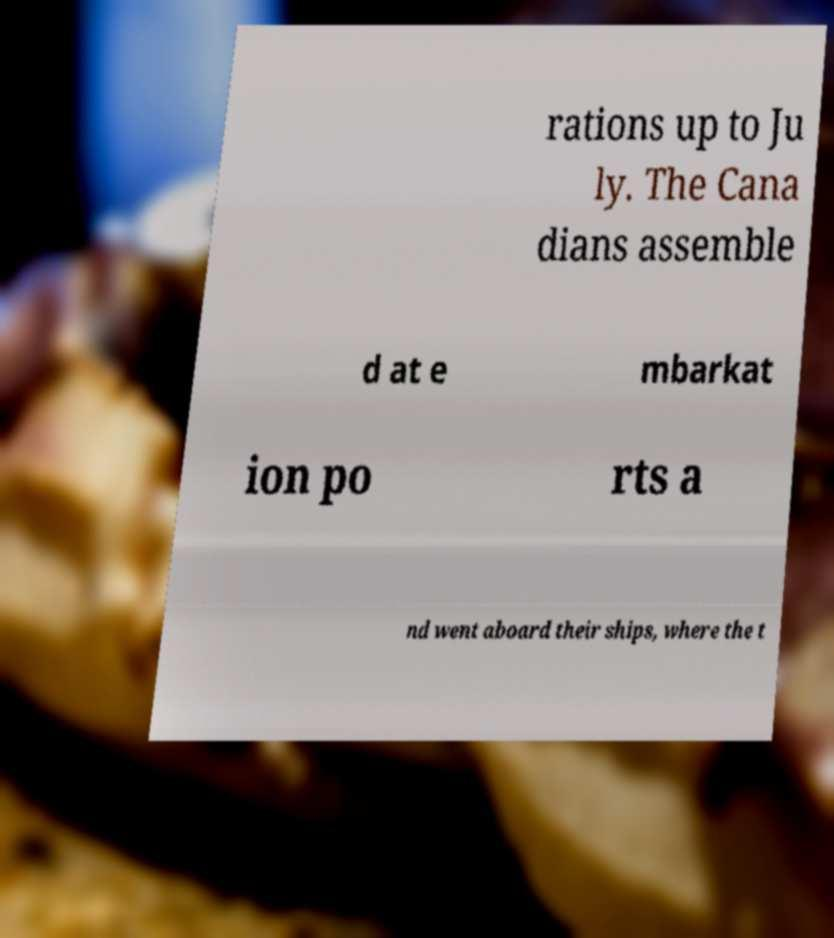Can you read and provide the text displayed in the image?This photo seems to have some interesting text. Can you extract and type it out for me? rations up to Ju ly. The Cana dians assemble d at e mbarkat ion po rts a nd went aboard their ships, where the t 